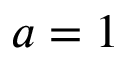Convert formula to latex. <formula><loc_0><loc_0><loc_500><loc_500>a = 1</formula> 